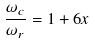Convert formula to latex. <formula><loc_0><loc_0><loc_500><loc_500>\frac { \omega _ { c } } { \omega _ { r } } = 1 + 6 x</formula> 